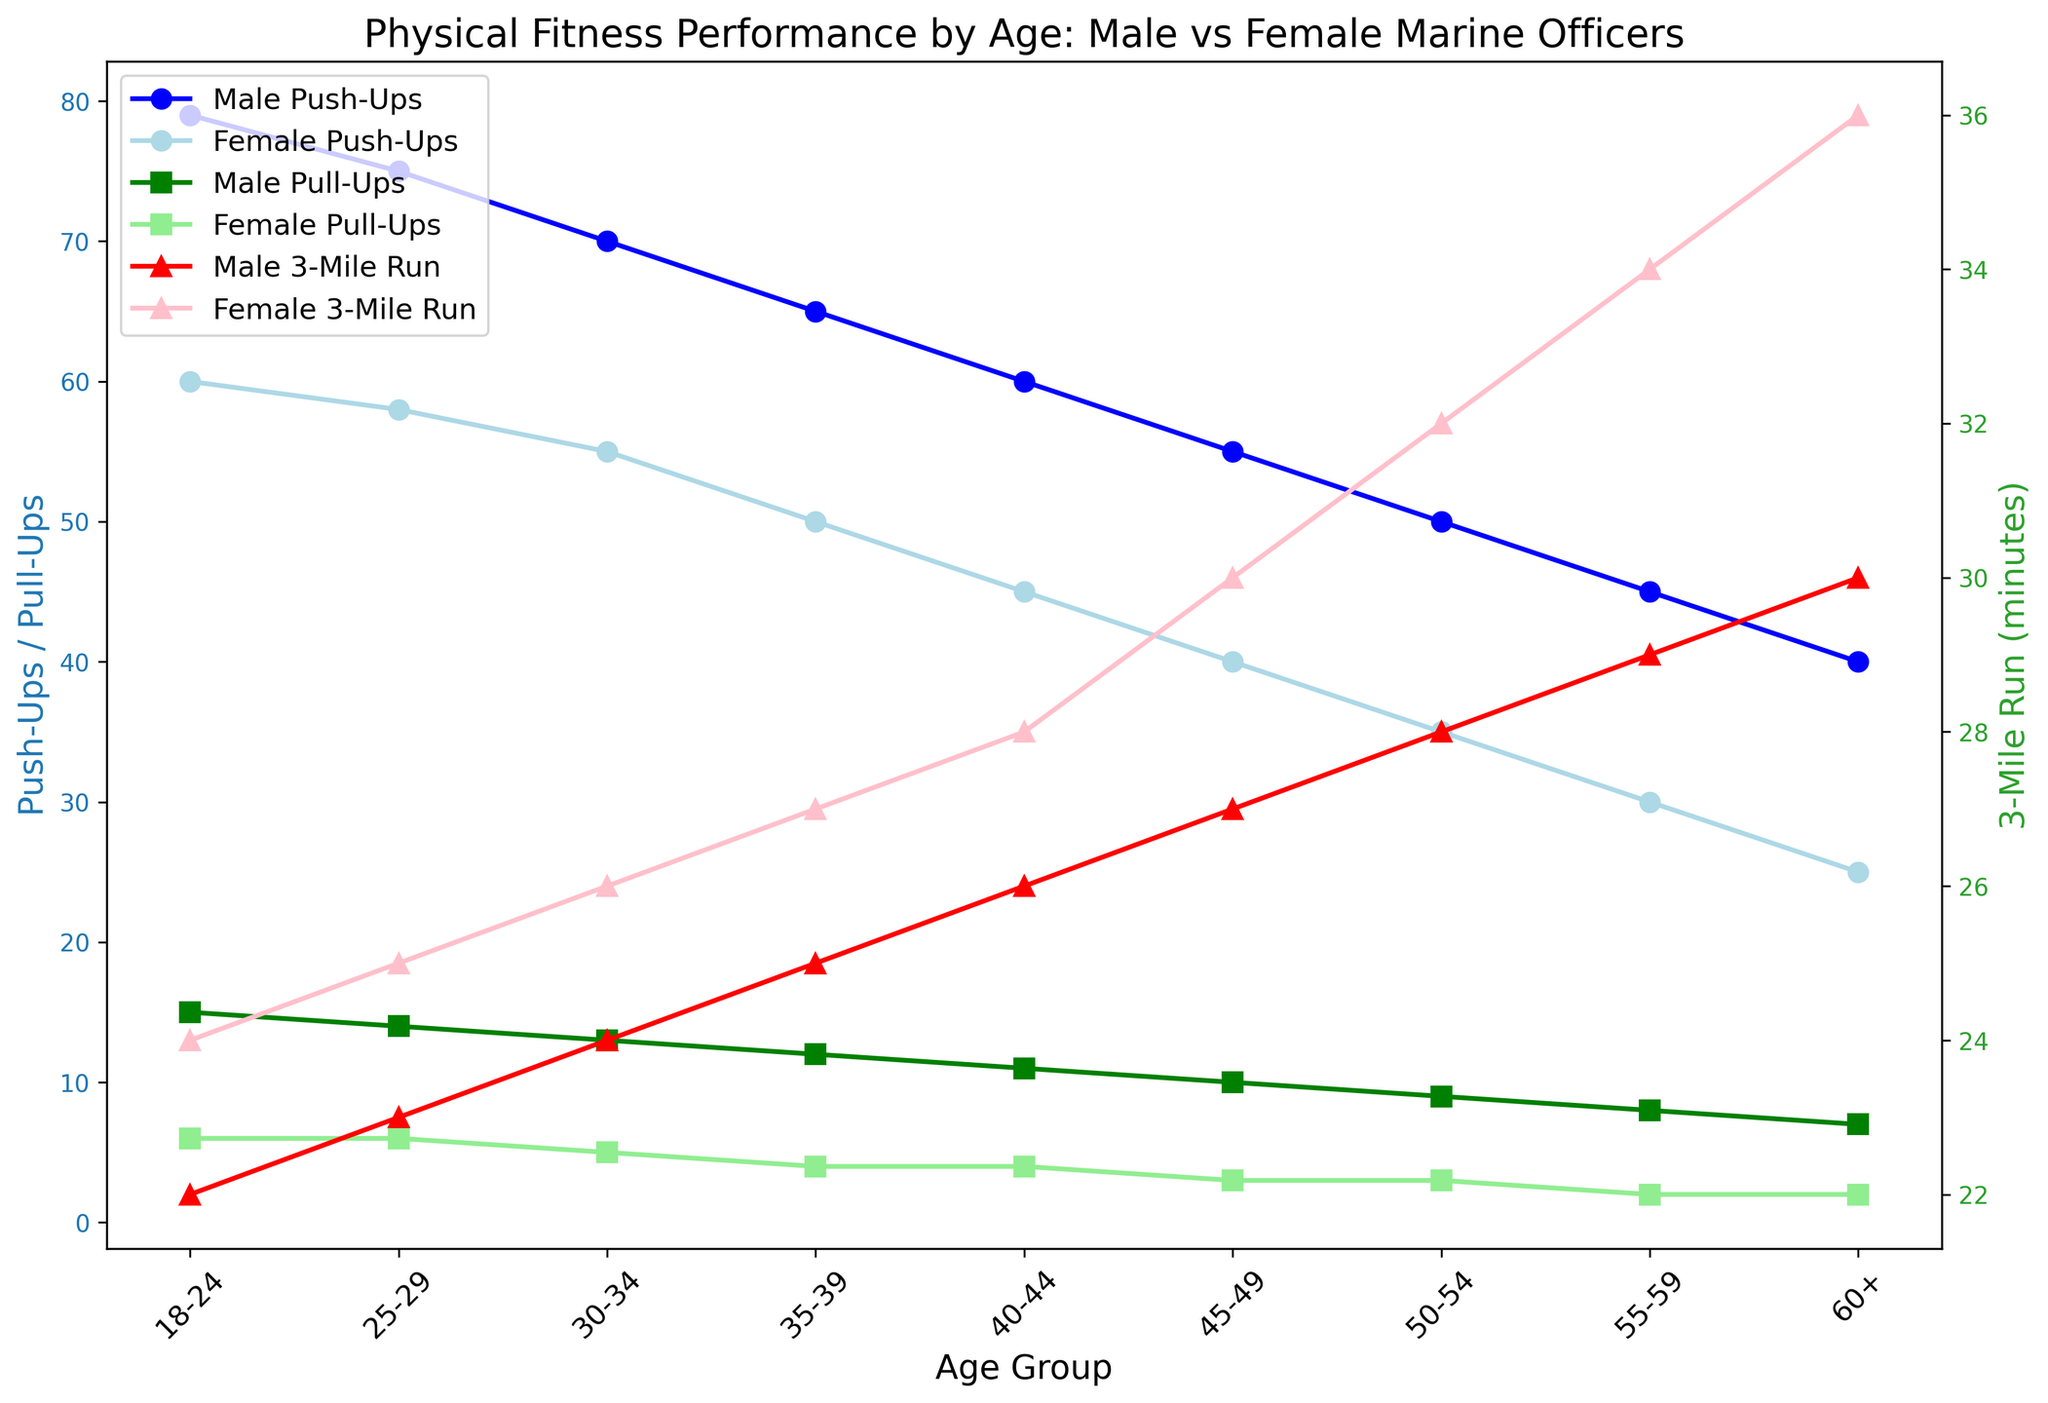What is the difference in the number of push-ups between male and female officers in the 18-24 age group? To find the difference in the number of push-ups between male and female officers in the 18-24 age group, subtract the female push-up count (60) from the male push-up count (79), which gives 79 - 60.
Answer: 19 How does the number of pull-ups change for male officers from the 30-34 to the 40-44 age group? To find the change, subtract the number of pull-ups in the 40-44 age group (11) from the number in the 30-34 age group (13): 13 - 11.
Answer: 2 Which age group has the highest average 3-mile run time for female officers? By examining the lines representing the 3-mile run time for females, the age group with the highest value is 60+ with a time of 36 minutes.
Answer: 60+ Between which age groups do male officers experience the biggest drop in average push-ups? To determine the biggest drop in push-ups, compare the differences between each consecutive pair of age groups and find the pair with the largest difference, which occurs from 18-24 (79 push-ups) to 25-29 (75 push-ups) where the drop is 79 - 75.
Answer: 18-24 to 25-29 Which age group shows the smallest difference between male and female pull-up averages? By comparing the differences in pull-up averages for each age group, the smallest difference is found in the 40-44 age group where males average 11 pull-ups and females average 4: 11 - 4.
Answer: 40-44 What is the average 3-mile run time for both male and female officers in the 45-49 age group? The average 3-mile run time for males in the 45-49 age group is 27 minutes, and for females, it's 30 minutes. The average of these two times is (27 + 30) / 2.
Answer: 28.5 How does the push-up count compare between males and females in the 55-59 age group? For the 55-59 age group, males average 45 push-ups while females average 30 push-ups. Thus, males perform 15 more push-ups than females.
Answer: 15 In which age group do male officers have the fastest average 3-mile run time? By examining the lines representing the 3-mile run time for male officers, the fastest (lowest) value is in the 18-24 age group with a time of 22 minutes.
Answer: 18-24 How many more push-ups do males in the 50-54 age group perform compared to females in the same age group? The average number of push-ups for males in the 50-54 age group is 50, while for females it is 35. Subtracting these gives 50 - 35.
Answer: 15 